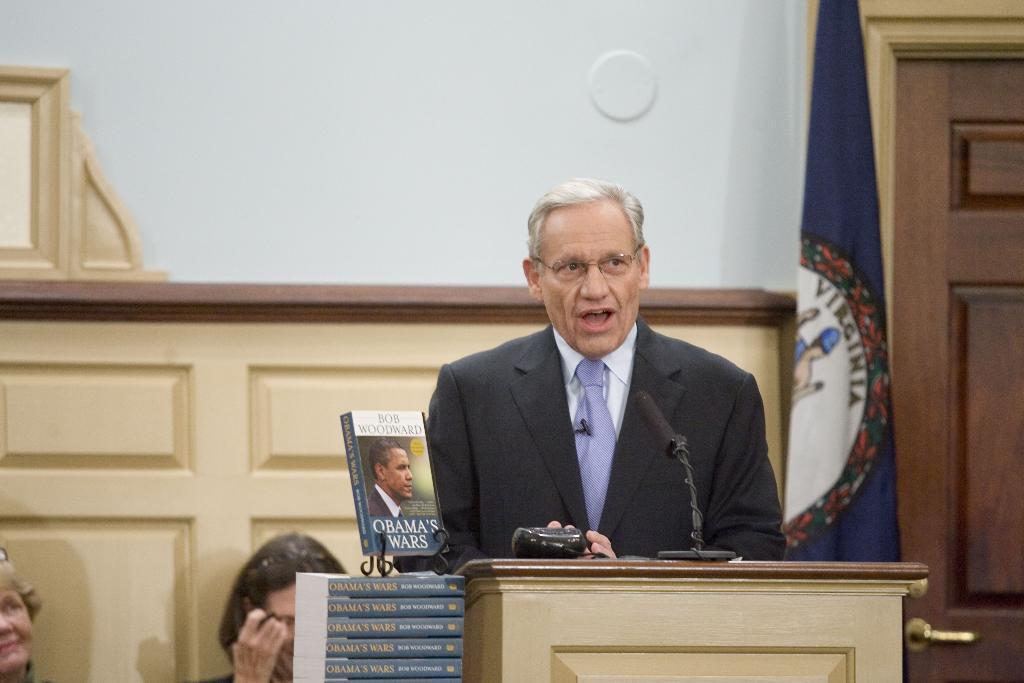Could you give a brief overview of what you see in this image? In the picture we can see a man standing near the desk and talking into the microphone and he is in a black blazer, tie and shirt and beside him we can see some books and written on it as Obama war and behind it, we can see two women are sitting near the wooden wall and beside it we can see a flag which is blue in color. 